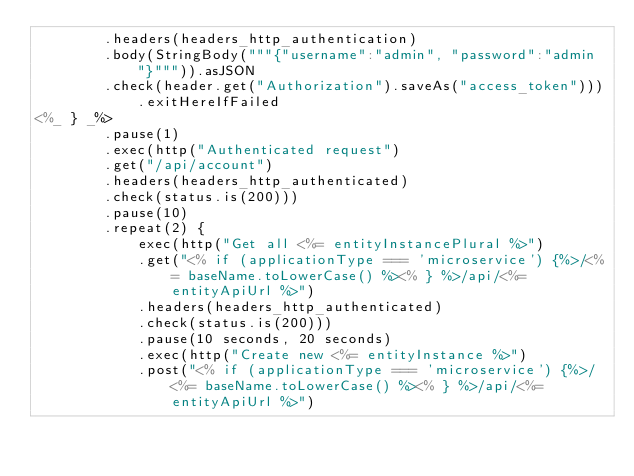<code> <loc_0><loc_0><loc_500><loc_500><_Scala_>        .headers(headers_http_authentication)
        .body(StringBody("""{"username":"admin", "password":"admin"}""")).asJSON
        .check(header.get("Authorization").saveAs("access_token"))).exitHereIfFailed
<%_ } _%>
        .pause(1)
        .exec(http("Authenticated request")
        .get("/api/account")
        .headers(headers_http_authenticated)
        .check(status.is(200)))
        .pause(10)
        .repeat(2) {
            exec(http("Get all <%= entityInstancePlural %>")
            .get("<% if (applicationType === 'microservice') {%>/<%= baseName.toLowerCase() %><% } %>/api/<%= entityApiUrl %>")
            .headers(headers_http_authenticated)
            .check(status.is(200)))
            .pause(10 seconds, 20 seconds)
            .exec(http("Create new <%= entityInstance %>")
            .post("<% if (applicationType === 'microservice') {%>/<%= baseName.toLowerCase() %><% } %>/api/<%= entityApiUrl %>")</code> 